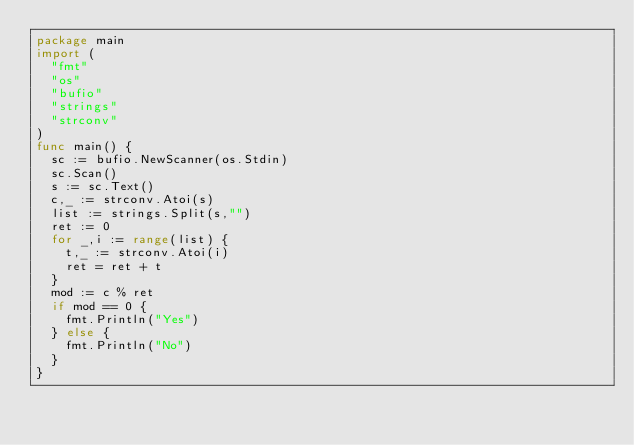Convert code to text. <code><loc_0><loc_0><loc_500><loc_500><_Go_>package main
import (
  "fmt"
  "os"
  "bufio"
  "strings"
  "strconv"
)
func main() {
  sc := bufio.NewScanner(os.Stdin)
  sc.Scan()
  s := sc.Text()
  c,_ := strconv.Atoi(s)
  list := strings.Split(s,"")
  ret := 0
  for _,i := range(list) {
    t,_ := strconv.Atoi(i)
    ret = ret + t
  }
  mod := c % ret
  if mod == 0 {
    fmt.Println("Yes")
  } else {
    fmt.Println("No")
  }
}</code> 